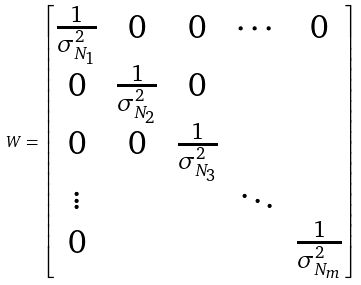<formula> <loc_0><loc_0><loc_500><loc_500>W = \begin{bmatrix} \frac { 1 } { \sigma ^ { 2 } _ { N _ { 1 } } } & 0 & 0 & \cdots & 0 \\ 0 & \frac { 1 } { \sigma ^ { 2 } _ { N _ { 2 } } } & 0 & & \\ 0 & 0 & \frac { 1 } { \sigma ^ { 2 } _ { N _ { 3 } } } & & \\ \vdots & & & \ddots & \\ 0 & & & & \frac { 1 } { \sigma ^ { 2 } _ { N _ { m } } } \end{bmatrix}</formula> 